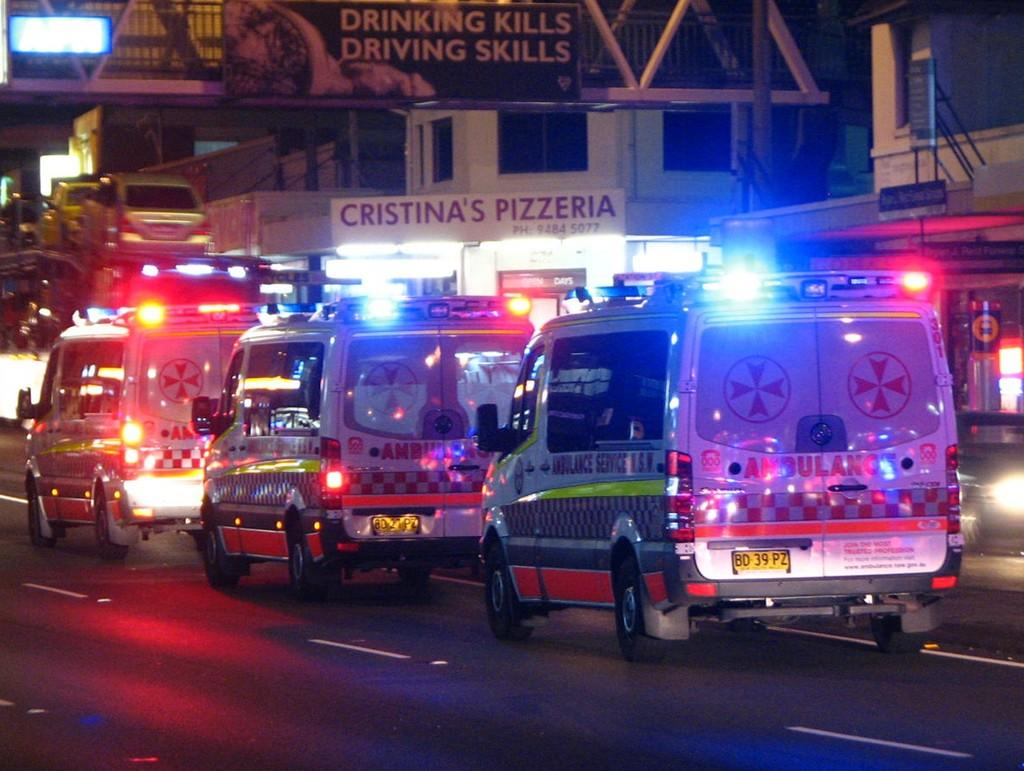What type of vehicles are parked on the road in the image? There are ambulances parked on the road in the image. What else can be seen in the background of the image? There is a group of cars, buildings, a sign board, and lights visible in the background. How many frogs are sitting on the furniture in the image? There are no frogs or furniture present in the image. 